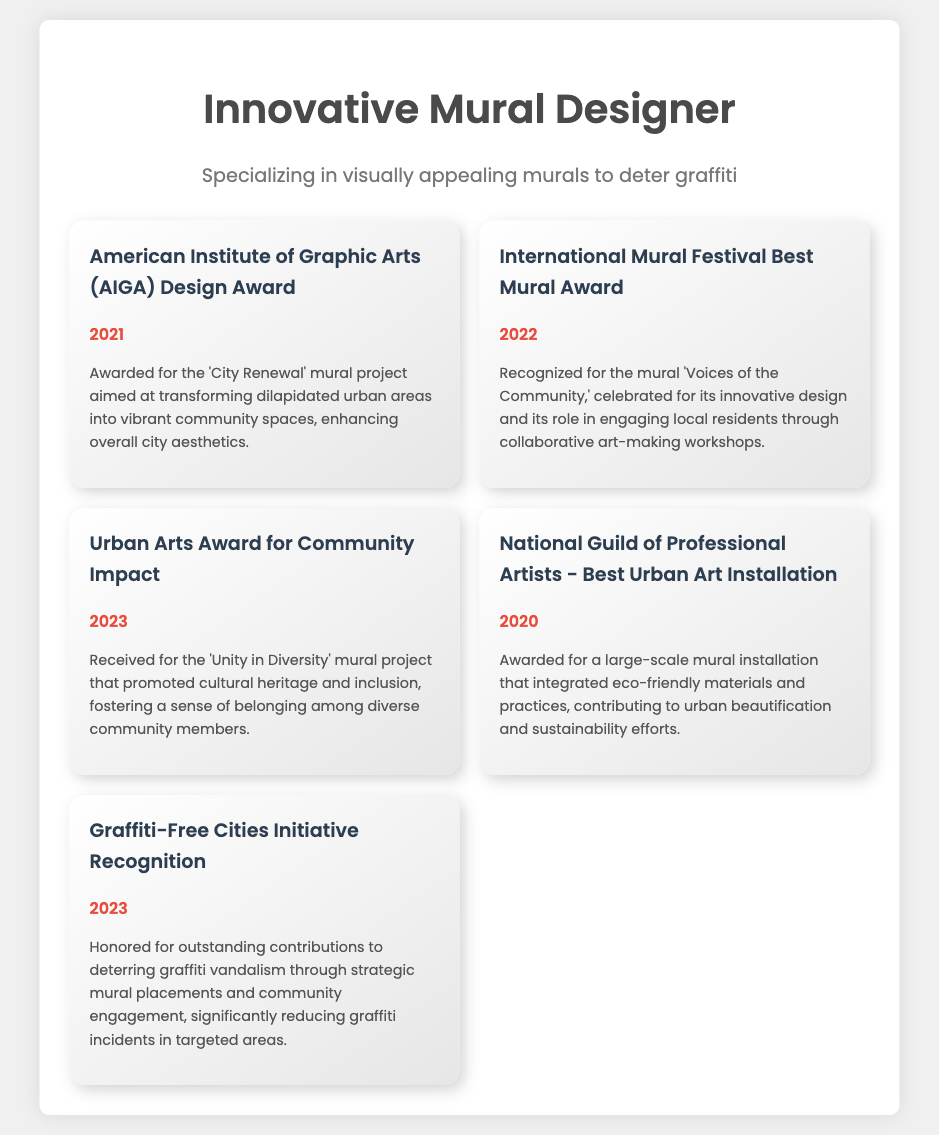what award did the designer receive from AIGA? The document states the designer received the American Institute of Graphic Arts (AIGA) Design Award in 2021.
Answer: American Institute of Graphic Arts (AIGA) Design Award what year was the 'Voices of the Community' mural recognized? The award for the 'Voices of the Community' mural was received in 2022.
Answer: 2022 which award was given for the 'Unity in Diversity' mural project? The document notes that the Urban Arts Award for Community Impact was awarded for the 'Unity in Diversity' mural project.
Answer: Urban Arts Award for Community Impact what is the theme of the mural recognized by the Graffiti-Free Cities Initiative in 2023? The theme of the mural recognized by the Graffiti-Free Cities Initiative is deterring graffiti vandalism through strategic placements and community engagement.
Answer: deterring graffiti vandalism how many awards were received in 2023? The document lists two awards received in 2023, the Urban Arts Award and the Graffiti-Free Cities Initiative Recognition.
Answer: 2 